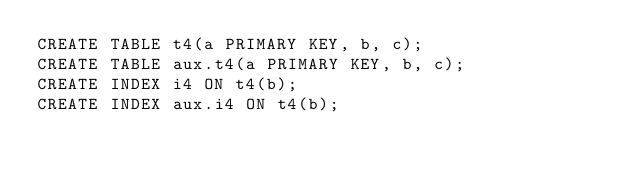Convert code to text. <code><loc_0><loc_0><loc_500><loc_500><_SQL_>CREATE TABLE t4(a PRIMARY KEY, b, c);
CREATE TABLE aux.t4(a PRIMARY KEY, b, c);
CREATE INDEX i4 ON t4(b);
CREATE INDEX aux.i4 ON t4(b);</code> 